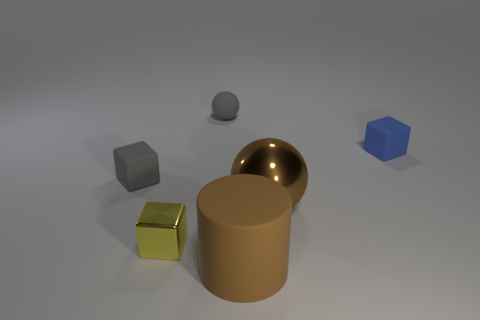What number of tiny things are either brown shiny spheres or green cylinders?
Keep it short and to the point. 0. Do the gray cube and the big brown ball have the same material?
Provide a succinct answer. No. There is a object that is the same color as the small matte sphere; what size is it?
Provide a succinct answer. Small. Is there a sphere that has the same color as the matte cylinder?
Ensure brevity in your answer.  Yes. What is the size of the blue thing that is the same material as the gray sphere?
Offer a very short reply. Small. There is a gray object that is in front of the blue thing that is behind the big object right of the rubber cylinder; what is its shape?
Provide a succinct answer. Cube. The gray rubber thing that is the same shape as the tiny metal object is what size?
Your answer should be very brief. Small. How big is the object that is right of the big brown rubber thing and left of the tiny blue rubber thing?
Offer a very short reply. Large. There is a large metallic thing that is the same color as the matte cylinder; what shape is it?
Ensure brevity in your answer.  Sphere. The large ball has what color?
Your response must be concise. Brown. 